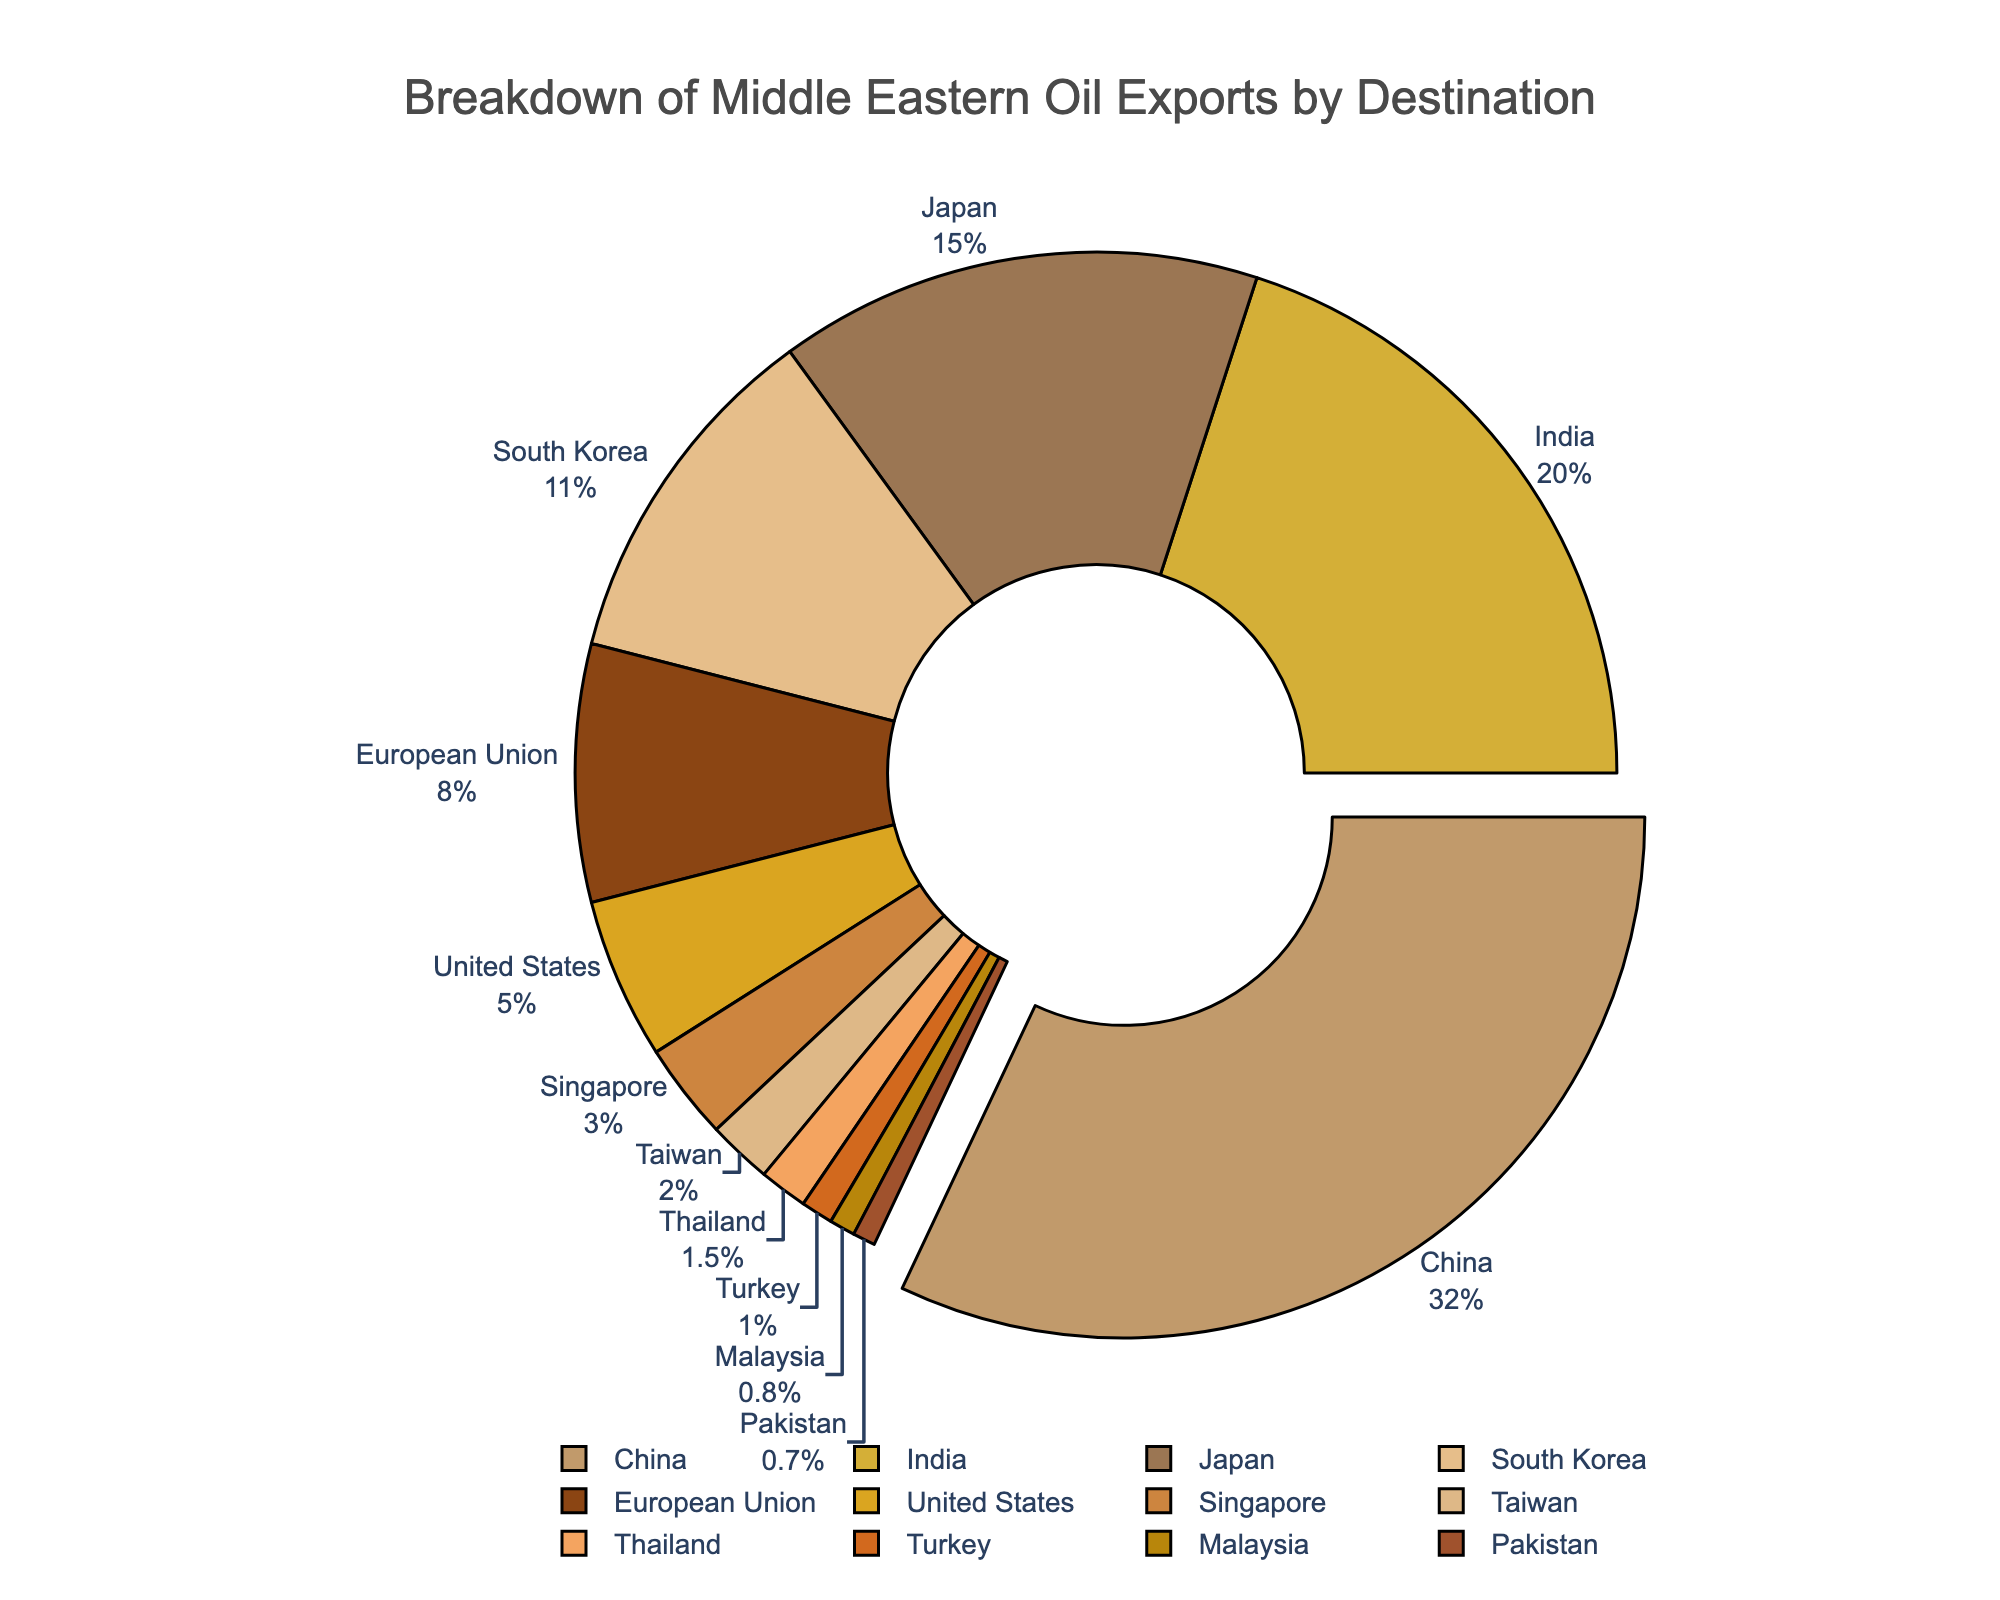Which country receives the largest percentage of Middle Eastern oil exports? Identify the country with the largest pie slice and the highest percentage value. This is China with 32%.
Answer: China What is the total percentage of oil exports going to India and Japan combined? Locate the percentages for India (20%) and Japan (15%) and sum them: 20 + 15 = 35.
Answer: 35% How does the percentage of oil exports to the United States compare to that to the European Union? Identify the percentage values for the United States (5%) and the European Union (8%), then compare: 5 < 8.
Answer: United States receives less What is the percentage difference between South Korea and Singapore? Identify South Korea's percentage (11%) and Singapore's percentage (3%), then subtract: 11 - 3 = 8.
Answer: 8% Which countries receive a combined total of less than 5% of oil exports? Identify all countries with percentages that sum to less than 5%: Turkey (1%), Malaysia (0.8%), and Pakistan (0.7%). Sum them: 1 + 0.8 + 0.7 = 2.5.
Answer: Turkey, Malaysia, Pakistan What is the average percentage of oil exports among China, India, and Japan? Sum the percentages for these three countries: 32 (China) + 20 (India) + 15 (Japan) = 67. Divide by 3 for the average: 67 / 3 ≈ 22.33.
Answer: 22.33% Which countries have oil export percentages in single digits? Identify all countries with percentages less than 10%: European Union (8%), United States (5%), Singapore (3%), Taiwan (2%), Thailand (1.5%), Turkey (1%), Malaysia (0.8%), and Pakistan (0.7%).
Answer: European Union, United States, Singapore, Taiwan, Thailand, Turkey, Malaysia, Pakistan What fraction of the total oil exports does South Korea receive? South Korea's percentage is 11%. The fraction is 11/100.
Answer: 11/100 How many countries receive more than 10% of Middle Eastern oil exports? Identify the countries with percentages greater than 10%: China (32%), India (20%), Japan (15%), South Korea (11%). Count these countries: 4.
Answer: 4 